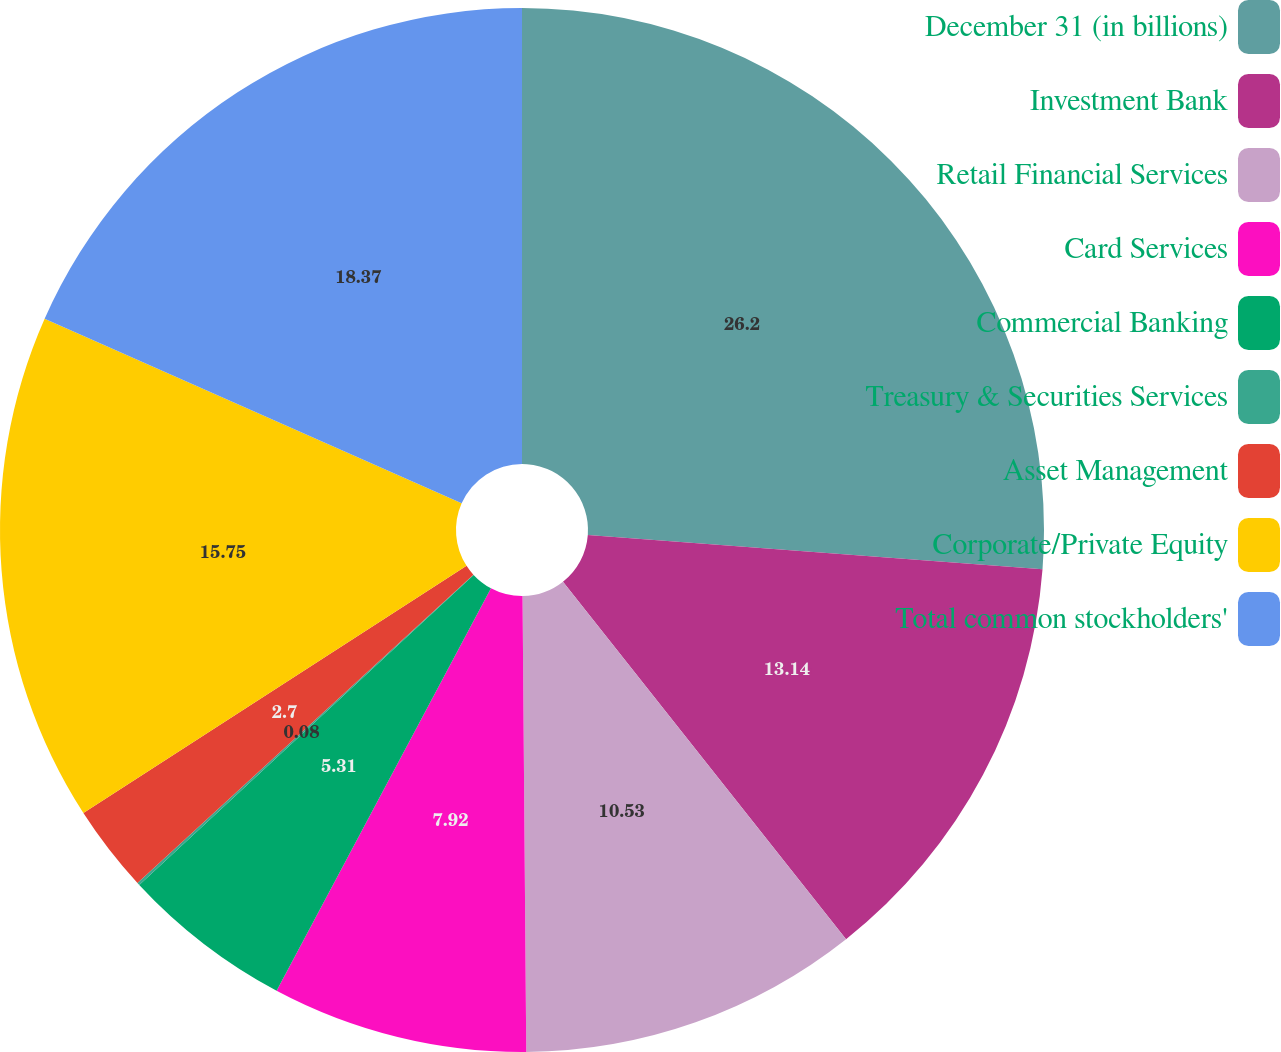Convert chart to OTSL. <chart><loc_0><loc_0><loc_500><loc_500><pie_chart><fcel>December 31 (in billions)<fcel>Investment Bank<fcel>Retail Financial Services<fcel>Card Services<fcel>Commercial Banking<fcel>Treasury & Securities Services<fcel>Asset Management<fcel>Corporate/Private Equity<fcel>Total common stockholders'<nl><fcel>26.2%<fcel>13.14%<fcel>10.53%<fcel>7.92%<fcel>5.31%<fcel>0.08%<fcel>2.7%<fcel>15.75%<fcel>18.37%<nl></chart> 